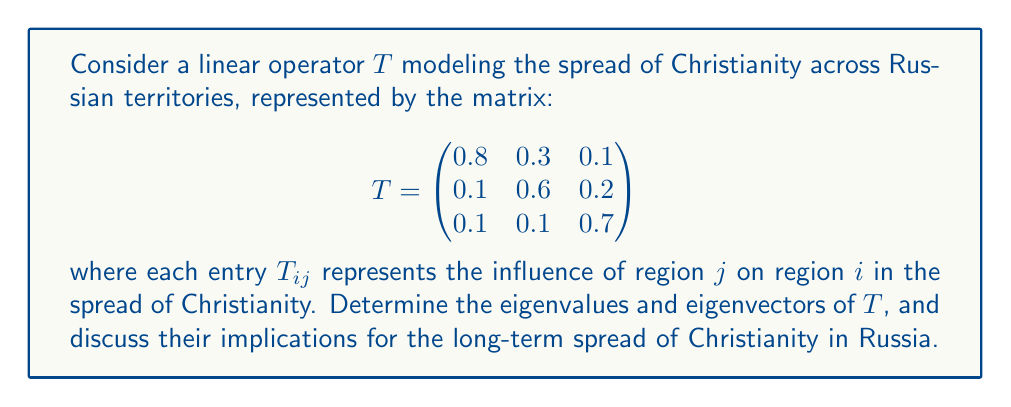What is the answer to this math problem? To determine the spectral properties of the linear operator $T$, we need to find its eigenvalues and eigenvectors.

Step 1: Find the characteristic polynomial
The characteristic polynomial is given by $det(T - \lambda I)$, where $I$ is the 3x3 identity matrix.

$$det(T - \lambda I) = \begin{vmatrix}
0.8 - \lambda & 0.3 & 0.1 \\
0.1 & 0.6 - \lambda & 0.2 \\
0.1 & 0.1 & 0.7 - \lambda
\end{vmatrix}$$

Step 2: Solve the characteristic equation
Expanding the determinant, we get:
$$(0.8 - \lambda)((0.6 - \lambda)(0.7 - \lambda) - 0.02) - 0.3(0.1(0.7 - \lambda) - 0.02) + 0.1(0.1(0.6 - \lambda) - 0.02) = 0$$

Simplifying:
$$-\lambda^3 + 2.1\lambda^2 - 1.46\lambda + 0.336 = 0$$

Step 3: Find the eigenvalues
Using a numerical method or computer algebra system, we find the roots of the characteristic polynomial:
$$\lambda_1 \approx 1, \lambda_2 \approx 0.7, \lambda_3 \approx 0.4$$

Step 4: Find the eigenvectors
For each eigenvalue $\lambda_i$, solve $(T - \lambda_i I)\vec{v} = \vec{0}$ to find the corresponding eigenvector $\vec{v}$.

For $\lambda_1 = 1$:
$$\vec{v}_1 \approx (0.707, 0.500, 0.500)^T$$

For $\lambda_2 = 0.7$:
$$\vec{v}_2 \approx (-0.408, 0.816, -0.408)^T$$

For $\lambda_3 = 0.4$:
$$\vec{v}_3 \approx (0.577, -0.577, 0.577)^T$$

Step 5: Interpret the results
The dominant eigenvalue $\lambda_1 = 1$ corresponds to the steady-state distribution of Christianity across the regions. The corresponding eigenvector $\vec{v}_1$ represents the relative strengths of Christianity in each region in the long term.

The other eigenvalues ($\lambda_2$ and $\lambda_3$) represent transient modes that will decay over time, as they are less than 1 in magnitude.
Answer: Eigenvalues: $\lambda_1 \approx 1, \lambda_2 \approx 0.7, \lambda_3 \approx 0.4$
Dominant eigenvector: $\vec{v}_1 \approx (0.707, 0.500, 0.500)^T$ 